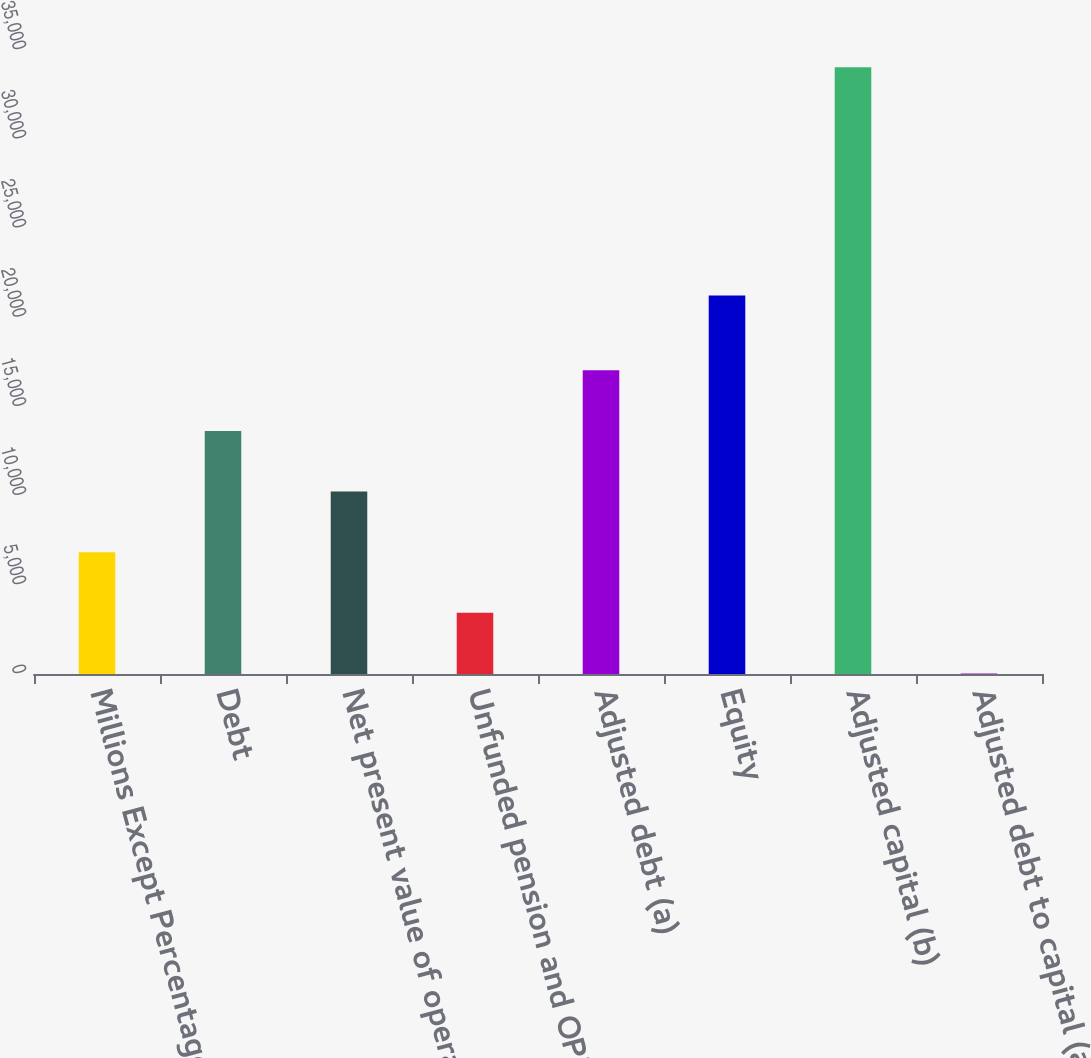Convert chart to OTSL. <chart><loc_0><loc_0><loc_500><loc_500><bar_chart><fcel>Millions Except Percentages<fcel>Debt<fcel>Net present value of operating<fcel>Unfunded pension and OPEB<fcel>Adjusted debt (a)<fcel>Equity<fcel>Adjusted capital (b)<fcel>Adjusted debt to capital (a/b)<nl><fcel>6835.88<fcel>13634.2<fcel>10235<fcel>3436.74<fcel>17033.3<fcel>21225<fcel>34029<fcel>37.6<nl></chart> 